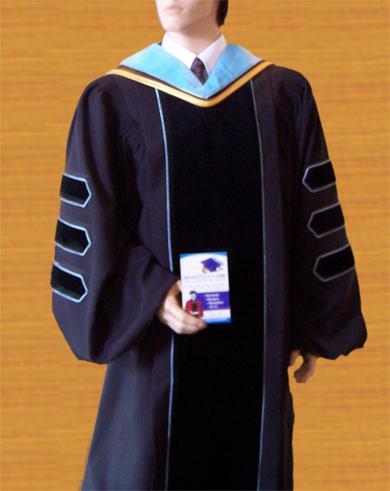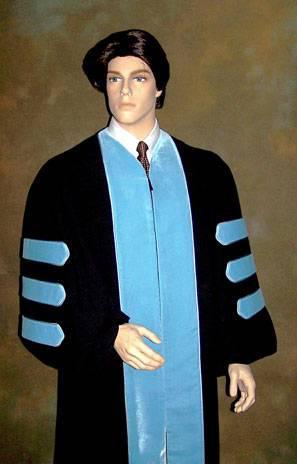The first image is the image on the left, the second image is the image on the right. Analyze the images presented: Is the assertion "At least one image shows a mannequin modeling a graduation robe with three stripes on each sleeve." valid? Answer yes or no. Yes. The first image is the image on the left, the second image is the image on the right. Assess this claim about the two images: "The right image contains a mannequin wearing a graduation gown.". Correct or not? Answer yes or no. Yes. 